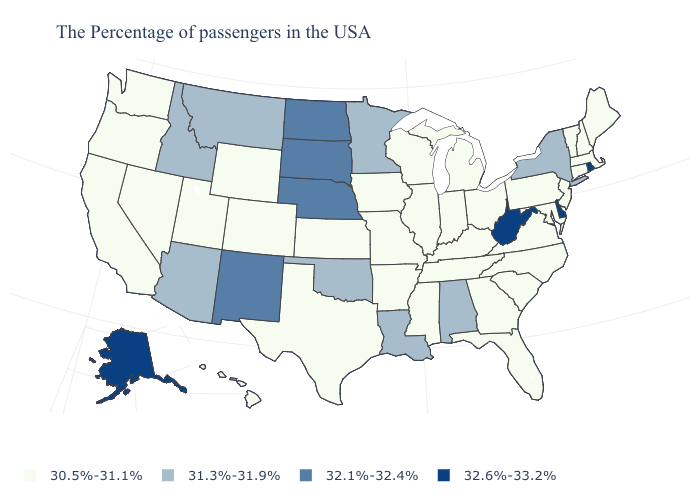Among the states that border North Carolina , which have the lowest value?
Concise answer only. Virginia, South Carolina, Georgia, Tennessee. Does the map have missing data?
Write a very short answer. No. Does Nevada have a lower value than Delaware?
Keep it brief. Yes. What is the value of Illinois?
Write a very short answer. 30.5%-31.1%. What is the highest value in states that border Tennessee?
Keep it brief. 31.3%-31.9%. What is the value of New Hampshire?
Answer briefly. 30.5%-31.1%. Name the states that have a value in the range 32.1%-32.4%?
Keep it brief. Nebraska, South Dakota, North Dakota, New Mexico. What is the value of Montana?
Concise answer only. 31.3%-31.9%. What is the value of New York?
Keep it brief. 31.3%-31.9%. Does the first symbol in the legend represent the smallest category?
Be succinct. Yes. What is the value of North Dakota?
Keep it brief. 32.1%-32.4%. Which states have the lowest value in the USA?
Short answer required. Maine, Massachusetts, New Hampshire, Vermont, Connecticut, New Jersey, Maryland, Pennsylvania, Virginia, North Carolina, South Carolina, Ohio, Florida, Georgia, Michigan, Kentucky, Indiana, Tennessee, Wisconsin, Illinois, Mississippi, Missouri, Arkansas, Iowa, Kansas, Texas, Wyoming, Colorado, Utah, Nevada, California, Washington, Oregon, Hawaii. Name the states that have a value in the range 30.5%-31.1%?
Answer briefly. Maine, Massachusetts, New Hampshire, Vermont, Connecticut, New Jersey, Maryland, Pennsylvania, Virginia, North Carolina, South Carolina, Ohio, Florida, Georgia, Michigan, Kentucky, Indiana, Tennessee, Wisconsin, Illinois, Mississippi, Missouri, Arkansas, Iowa, Kansas, Texas, Wyoming, Colorado, Utah, Nevada, California, Washington, Oregon, Hawaii. Does Delaware have the highest value in the USA?
Concise answer only. Yes. Name the states that have a value in the range 30.5%-31.1%?
Short answer required. Maine, Massachusetts, New Hampshire, Vermont, Connecticut, New Jersey, Maryland, Pennsylvania, Virginia, North Carolina, South Carolina, Ohio, Florida, Georgia, Michigan, Kentucky, Indiana, Tennessee, Wisconsin, Illinois, Mississippi, Missouri, Arkansas, Iowa, Kansas, Texas, Wyoming, Colorado, Utah, Nevada, California, Washington, Oregon, Hawaii. 